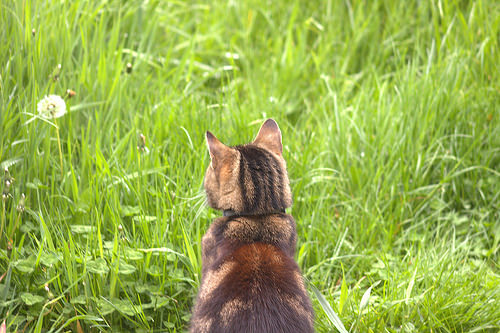<image>
Is there a cat on the grace? Yes. Looking at the image, I can see the cat is positioned on top of the grace, with the grace providing support. Is the cat next to the grass? Yes. The cat is positioned adjacent to the grass, located nearby in the same general area. Where is the cat in relation to the grass? Is it in front of the grass? Yes. The cat is positioned in front of the grass, appearing closer to the camera viewpoint. 